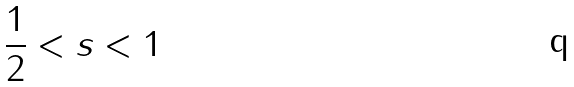Convert formula to latex. <formula><loc_0><loc_0><loc_500><loc_500>\frac { 1 } { 2 } < s < 1</formula> 